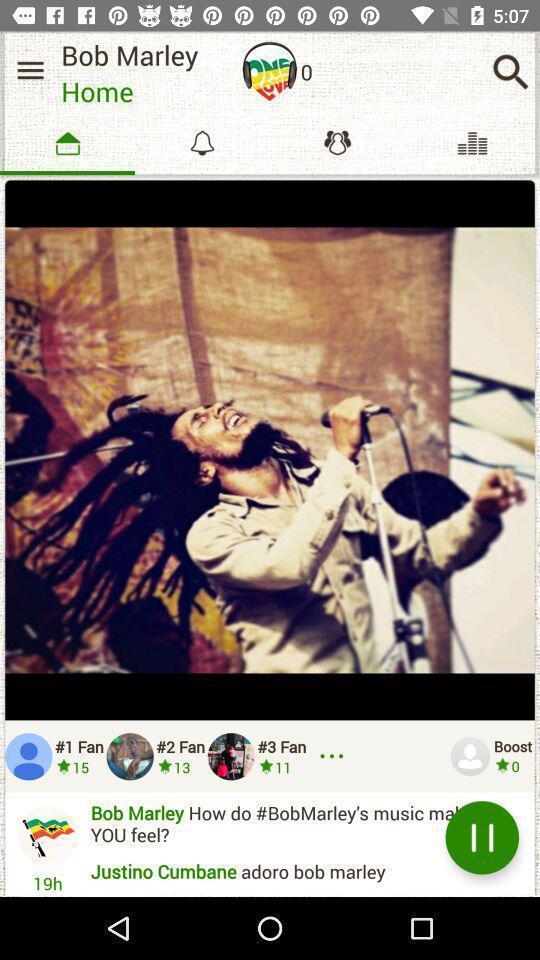Summarize the information in this screenshot. Page displaying homepage informations of a social application. 